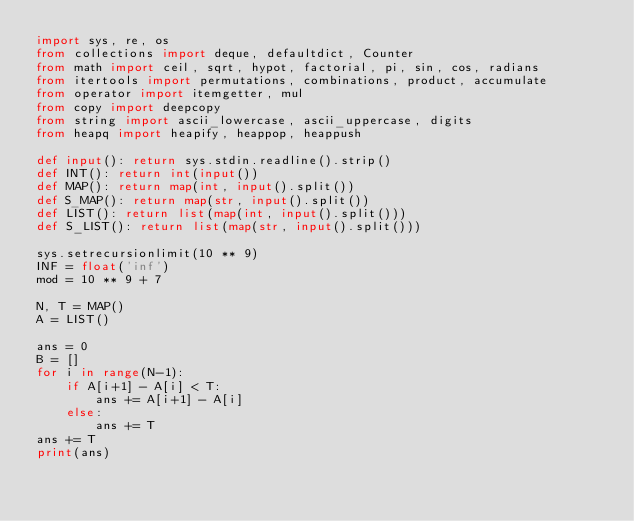<code> <loc_0><loc_0><loc_500><loc_500><_Python_>import sys, re, os
from collections import deque, defaultdict, Counter
from math import ceil, sqrt, hypot, factorial, pi, sin, cos, radians
from itertools import permutations, combinations, product, accumulate
from operator import itemgetter, mul
from copy import deepcopy
from string import ascii_lowercase, ascii_uppercase, digits
from heapq import heapify, heappop, heappush
 
def input(): return sys.stdin.readline().strip()
def INT(): return int(input())
def MAP(): return map(int, input().split())
def S_MAP(): return map(str, input().split())
def LIST(): return list(map(int, input().split()))
def S_LIST(): return list(map(str, input().split()))
 
sys.setrecursionlimit(10 ** 9)
INF = float('inf')
mod = 10 ** 9 + 7

N, T = MAP()
A = LIST()

ans = 0
B = []
for i in range(N-1):
    if A[i+1] - A[i] < T:
        ans += A[i+1] - A[i]
    else:
        ans += T
ans += T
print(ans)


</code> 